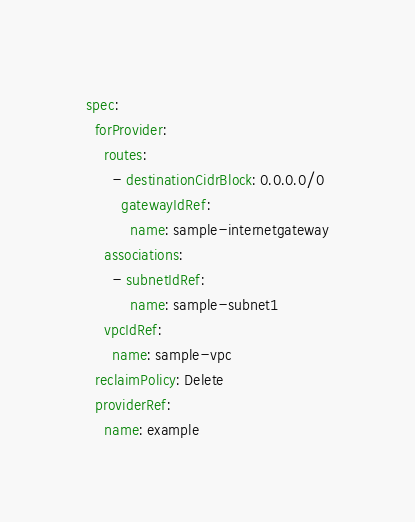<code> <loc_0><loc_0><loc_500><loc_500><_YAML_>spec:
  forProvider:
    routes:
      - destinationCidrBlock: 0.0.0.0/0
        gatewayIdRef:
          name: sample-internetgateway
    associations:
      - subnetIdRef:
          name: sample-subnet1
    vpcIdRef:
      name: sample-vpc
  reclaimPolicy: Delete
  providerRef:
    name: example</code> 